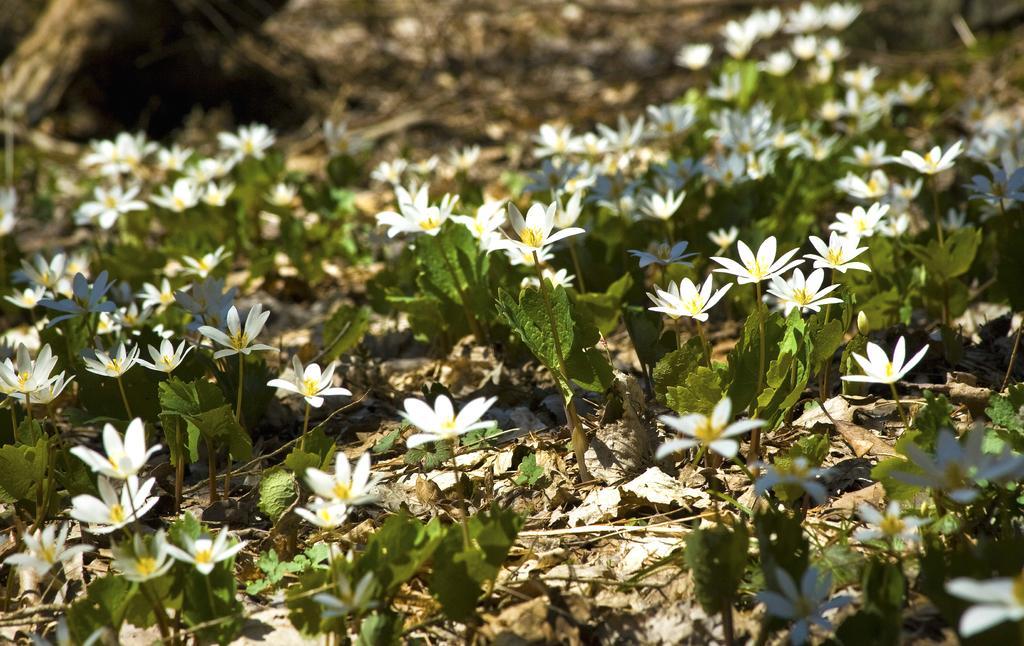In one or two sentences, can you explain what this image depicts? In this image we can see white color flower plants and dry leaves on the land. We can see a bark of a tree in the left top of the image. 